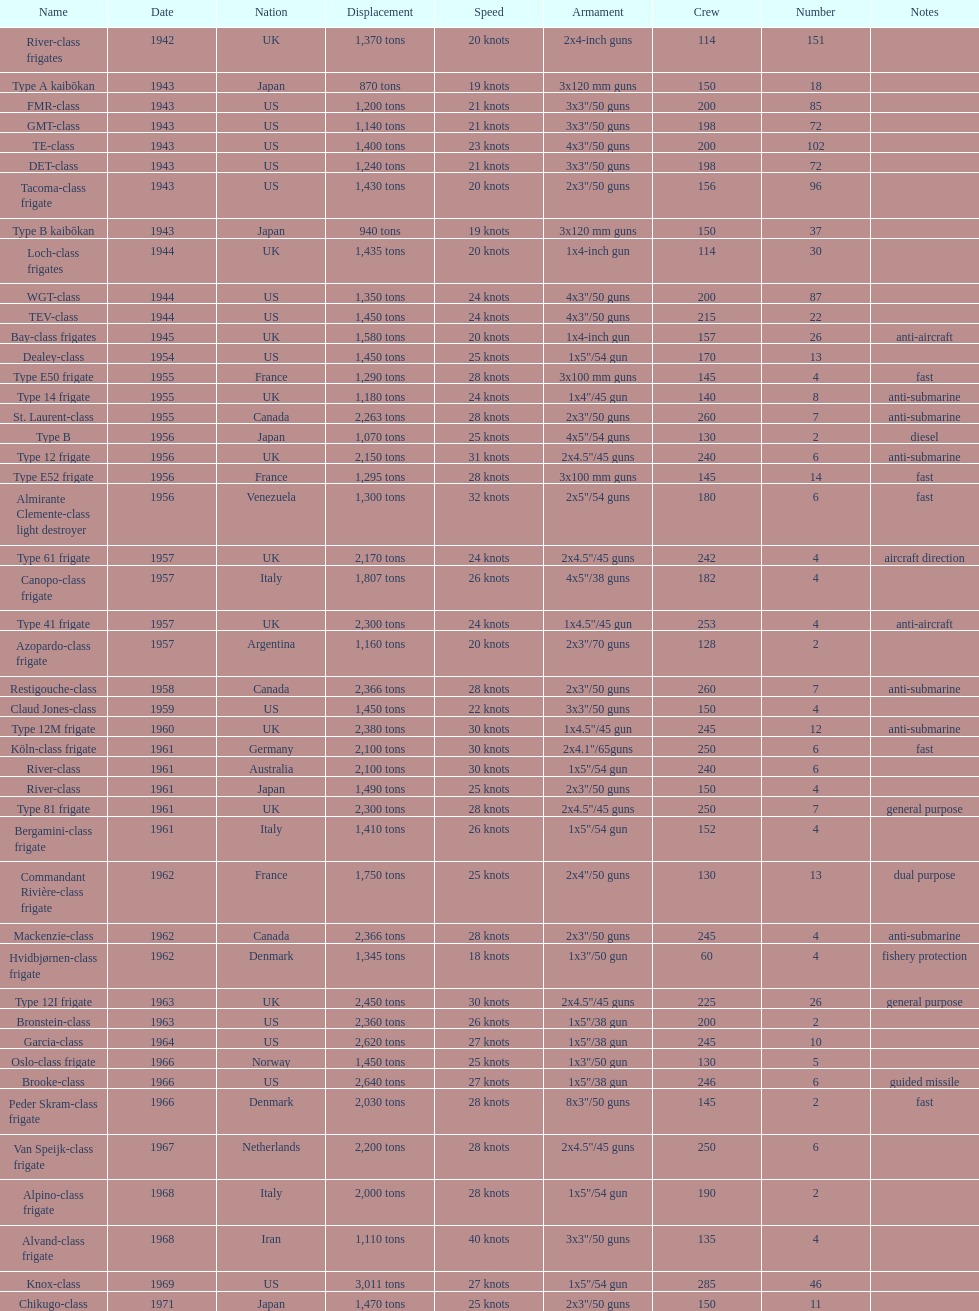What is the top speed? 40 knots. 